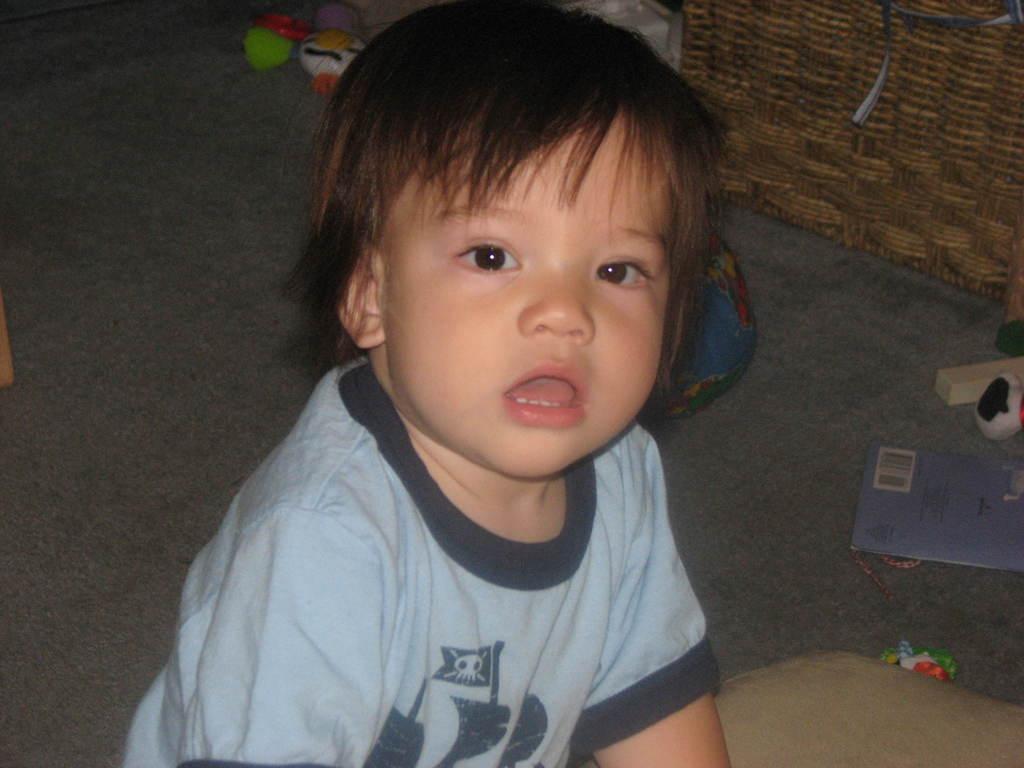How would you summarize this image in a sentence or two? In the center of the picture there is a kid. On the right there are toys, book and a basket. At the top there are toys. On the left there is an object on the floor. 